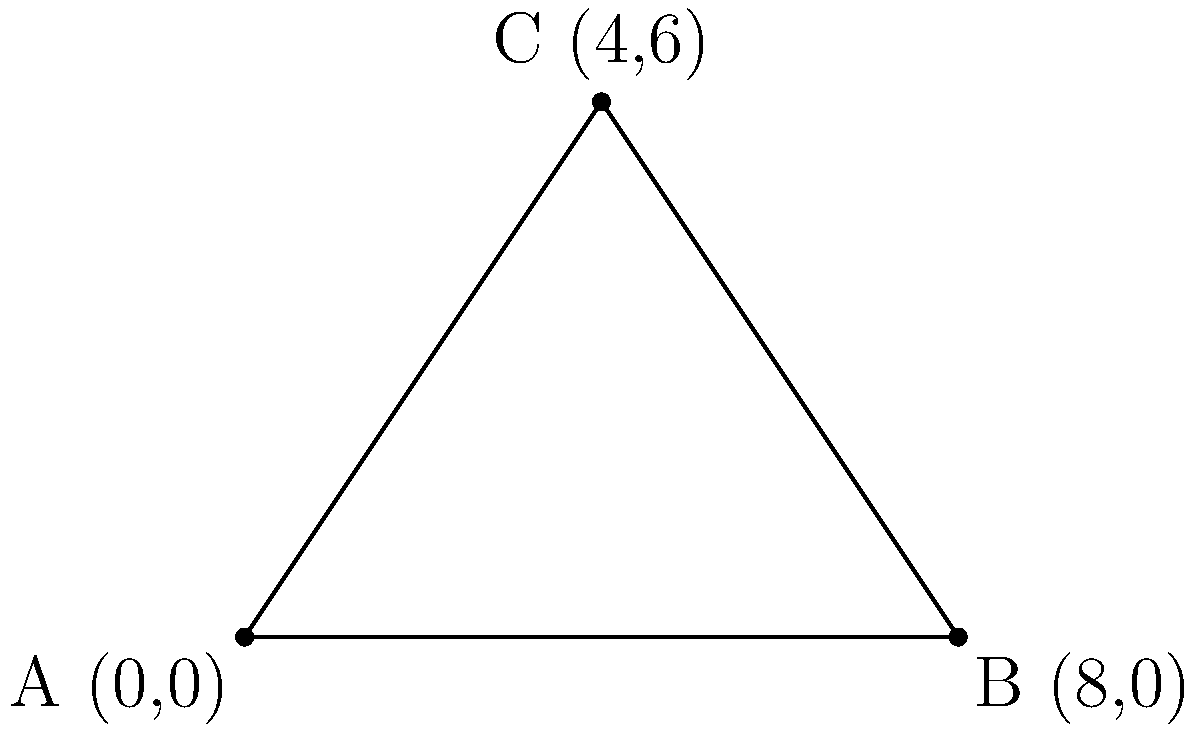During a crucial play, three Tiger-Cats players form a triangular formation on the field. Player A is at the origin (0,0), Player B is at (8,0), and Player C is at (4,6). Calculate the area of the triangle formed by these players' positions. Let's approach this step-by-step:

1) We can use the formula for the area of a triangle given the coordinates of its vertices:

   Area = $\frac{1}{2}|x_1(y_2 - y_3) + x_2(y_3 - y_1) + x_3(y_1 - y_2)|$

   Where $(x_1, y_1)$, $(x_2, y_2)$, and $(x_3, y_3)$ are the coordinates of the three vertices.

2) We have:
   A: $(x_1, y_1) = (0, 0)$
   B: $(x_2, y_2) = (8, 0)$
   C: $(x_3, y_3) = (4, 6)$

3) Let's substitute these into our formula:

   Area = $\frac{1}{2}|0(0 - 6) + 8(6 - 0) + 4(0 - 0)|$

4) Simplify:
   Area = $\frac{1}{2}|0 + 48 + 0|$

5) Calculate:
   Area = $\frac{1}{2}(48) = 24$

Therefore, the area of the triangle formed by the three Tiger-Cats players is 24 square units.
Answer: 24 square units 